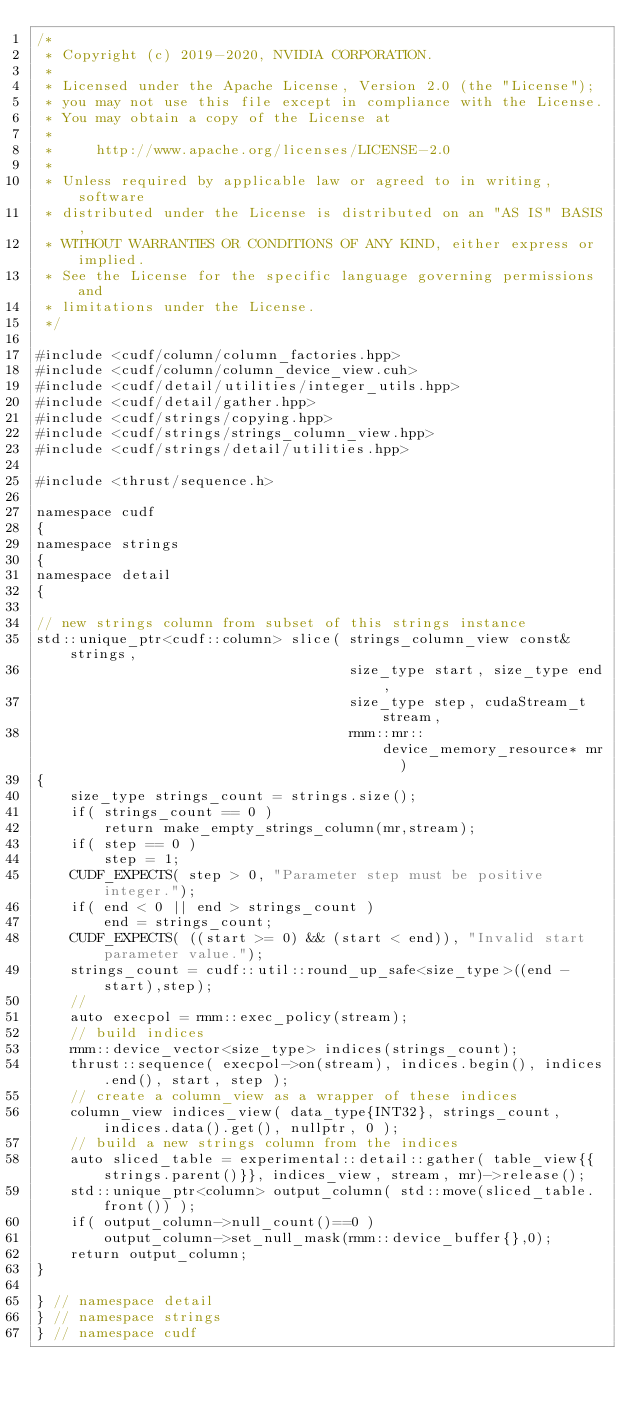<code> <loc_0><loc_0><loc_500><loc_500><_Cuda_>/*
 * Copyright (c) 2019-2020, NVIDIA CORPORATION.
 *
 * Licensed under the Apache License, Version 2.0 (the "License");
 * you may not use this file except in compliance with the License.
 * You may obtain a copy of the License at
 *
 *     http://www.apache.org/licenses/LICENSE-2.0
 *
 * Unless required by applicable law or agreed to in writing, software
 * distributed under the License is distributed on an "AS IS" BASIS,
 * WITHOUT WARRANTIES OR CONDITIONS OF ANY KIND, either express or implied.
 * See the License for the specific language governing permissions and
 * limitations under the License.
 */

#include <cudf/column/column_factories.hpp>
#include <cudf/column/column_device_view.cuh>
#include <cudf/detail/utilities/integer_utils.hpp>
#include <cudf/detail/gather.hpp>
#include <cudf/strings/copying.hpp>
#include <cudf/strings/strings_column_view.hpp>
#include <cudf/strings/detail/utilities.hpp>

#include <thrust/sequence.h>

namespace cudf
{
namespace strings
{
namespace detail
{

// new strings column from subset of this strings instance
std::unique_ptr<cudf::column> slice( strings_column_view const& strings,
                                     size_type start, size_type end,
                                     size_type step, cudaStream_t stream,
                                     rmm::mr::device_memory_resource* mr  )
{
    size_type strings_count = strings.size();
    if( strings_count == 0 )
        return make_empty_strings_column(mr,stream);
    if( step == 0 )
        step = 1;
    CUDF_EXPECTS( step > 0, "Parameter step must be positive integer.");
    if( end < 0 || end > strings_count )
        end = strings_count;
    CUDF_EXPECTS( ((start >= 0) && (start < end)), "Invalid start parameter value.");
    strings_count = cudf::util::round_up_safe<size_type>((end - start),step);
    //
    auto execpol = rmm::exec_policy(stream);
    // build indices
    rmm::device_vector<size_type> indices(strings_count);
    thrust::sequence( execpol->on(stream), indices.begin(), indices.end(), start, step );
    // create a column_view as a wrapper of these indices
    column_view indices_view( data_type{INT32}, strings_count, indices.data().get(), nullptr, 0 );
    // build a new strings column from the indices
    auto sliced_table = experimental::detail::gather( table_view{{strings.parent()}}, indices_view, stream, mr)->release();
    std::unique_ptr<column> output_column( std::move(sliced_table.front()) );
    if( output_column->null_count()==0 )
        output_column->set_null_mask(rmm::device_buffer{},0);
    return output_column;
}

} // namespace detail
} // namespace strings
} // namespace cudf
</code> 